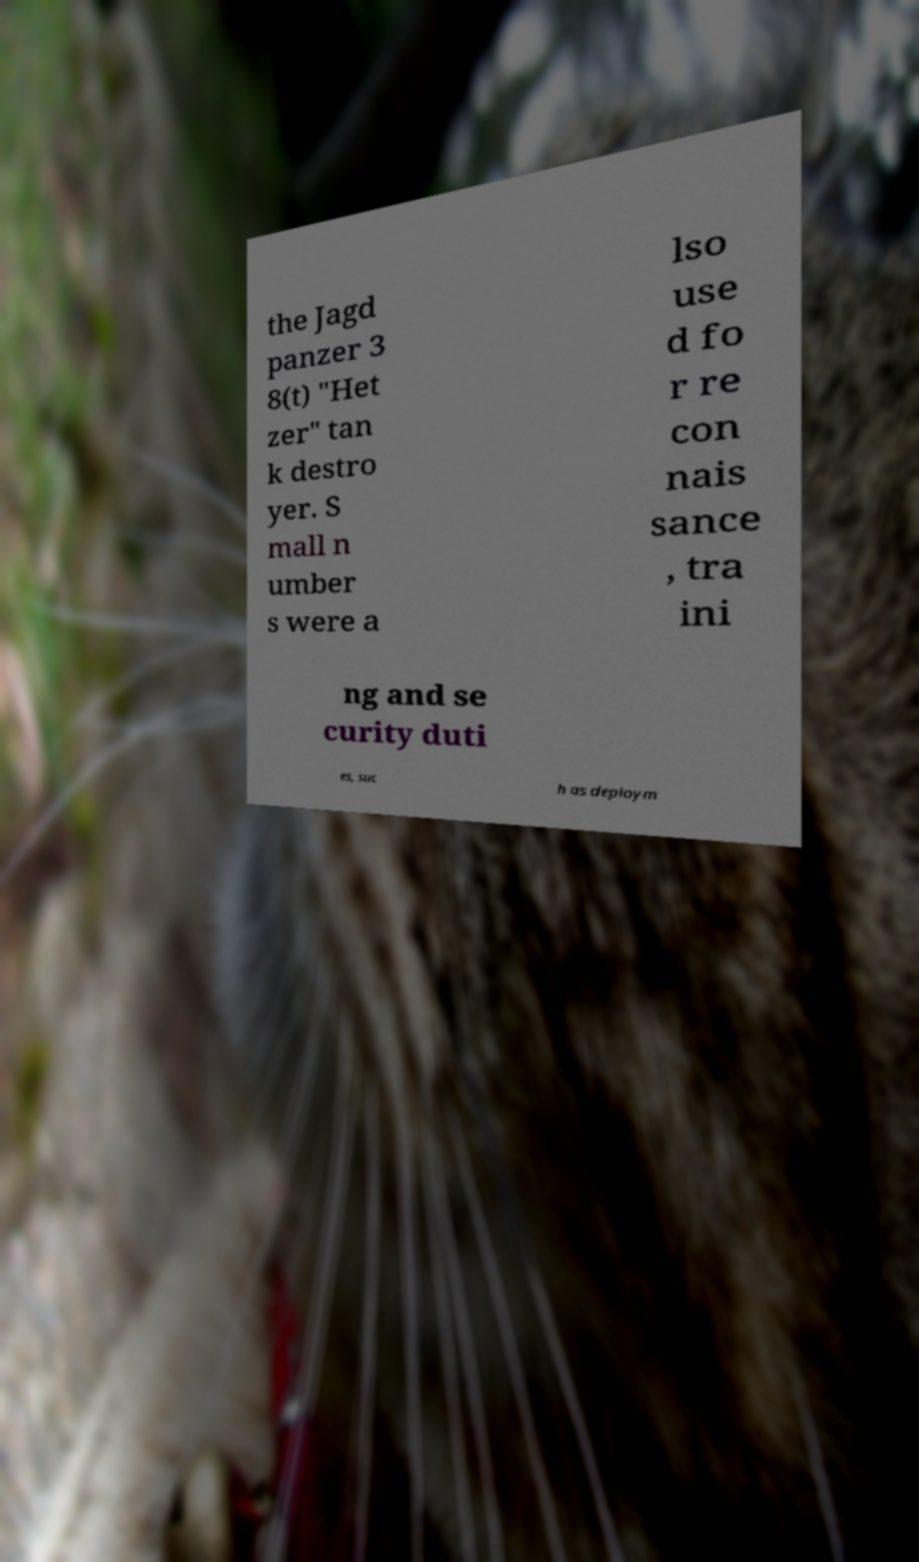Can you read and provide the text displayed in the image?This photo seems to have some interesting text. Can you extract and type it out for me? the Jagd panzer 3 8(t) "Het zer" tan k destro yer. S mall n umber s were a lso use d fo r re con nais sance , tra ini ng and se curity duti es, suc h as deploym 